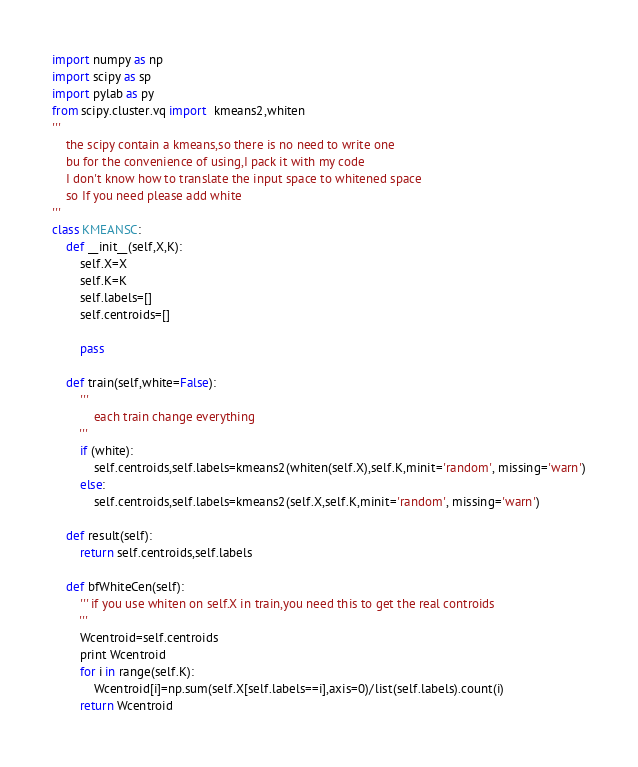<code> <loc_0><loc_0><loc_500><loc_500><_Python_>import numpy as np
import scipy as sp
import pylab as py
from scipy.cluster.vq import  kmeans2,whiten
'''
	the scipy contain a kmeans,so there is no need to write one
	bu for the convenience of using,I pack it with my code
	I don't know how to translate the input space to whitened space
	so If you need please add white
'''
class KMEANSC:
	def __init__(self,X,K):
		self.X=X
		self.K=K
		self.labels=[]
		self.centroids=[]
		
		pass
		
	def train(self,white=False):
		'''
			each train change everything
		'''
		if (white):
			self.centroids,self.labels=kmeans2(whiten(self.X),self.K,minit='random', missing='warn')
		else:
			self.centroids,self.labels=kmeans2(self.X,self.K,minit='random', missing='warn')
			
	def result(self):
		return self.centroids,self.labels
		
	def bfWhiteCen(self):
		''' if you use whiten on self.X in train,you need this to get the real controids
		'''
		Wcentroid=self.centroids
		print Wcentroid
		for i in range(self.K):
			Wcentroid[i]=np.sum(self.X[self.labels==i],axis=0)/list(self.labels).count(i)
		return Wcentroid</code> 